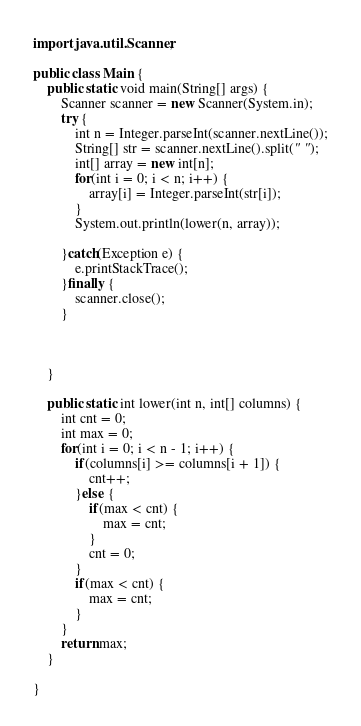Convert code to text. <code><loc_0><loc_0><loc_500><loc_500><_Java_>import java.util.Scanner;

public class Main {
	public static void main(String[] args) {
		Scanner scanner = new Scanner(System.in);
		try {
			int n = Integer.parseInt(scanner.nextLine());
			String[] str = scanner.nextLine().split(" ");
			int[] array = new int[n];
			for(int i = 0; i < n; i++) {
				array[i] = Integer.parseInt(str[i]);
			}
			System.out.println(lower(n, array));
			
		}catch(Exception e) {
			e.printStackTrace();
		}finally {
			scanner.close();
		}
		


	}
	
	public static int lower(int n, int[] columns) {
		int cnt = 0;
		int max = 0;
		for(int i = 0; i < n - 1; i++) {
			if(columns[i] >= columns[i + 1]) {
				cnt++;
			}else {
				if(max < cnt) {
					max = cnt;
				}
				cnt = 0;
			}
			if(max < cnt) {
				max = cnt;
			}
		}
		return max;
	}

}
</code> 